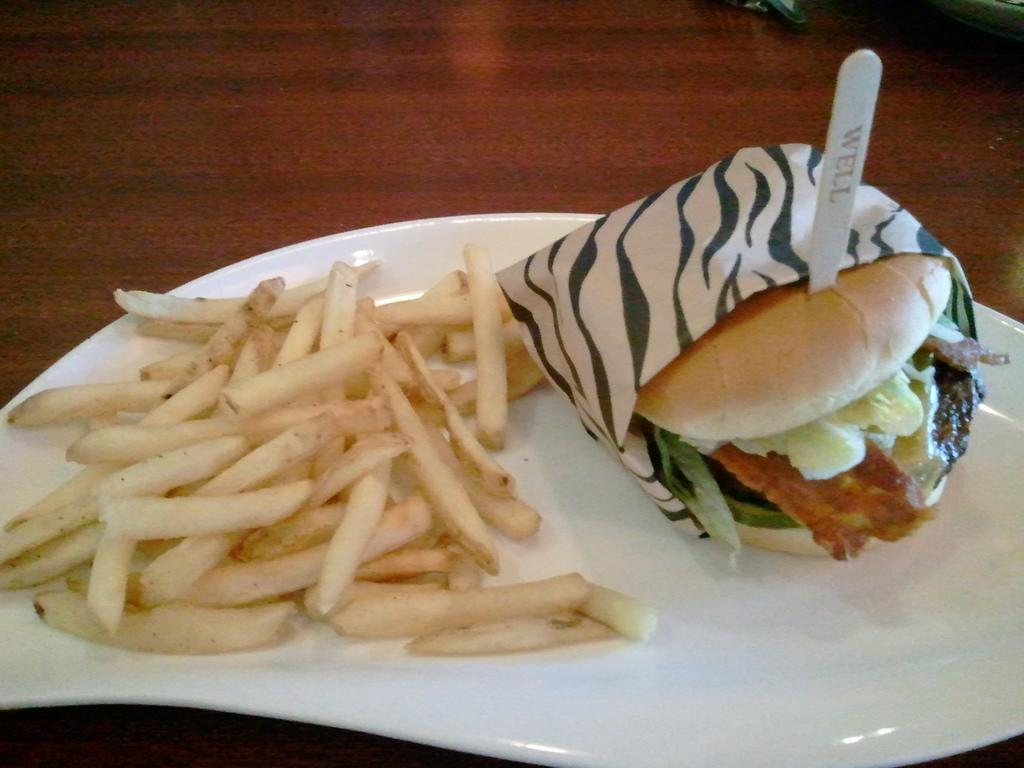What piece of furniture is present in the image? There is a table in the image. What is placed on the table? There is a plate on the table. What is on the plate? The plate contains food items. What utensil is present on the table? There is a spoon on the table. What grade is the apple on the table receiving in the image? There is no apple present in the image, so it is not possible to determine its grade. 